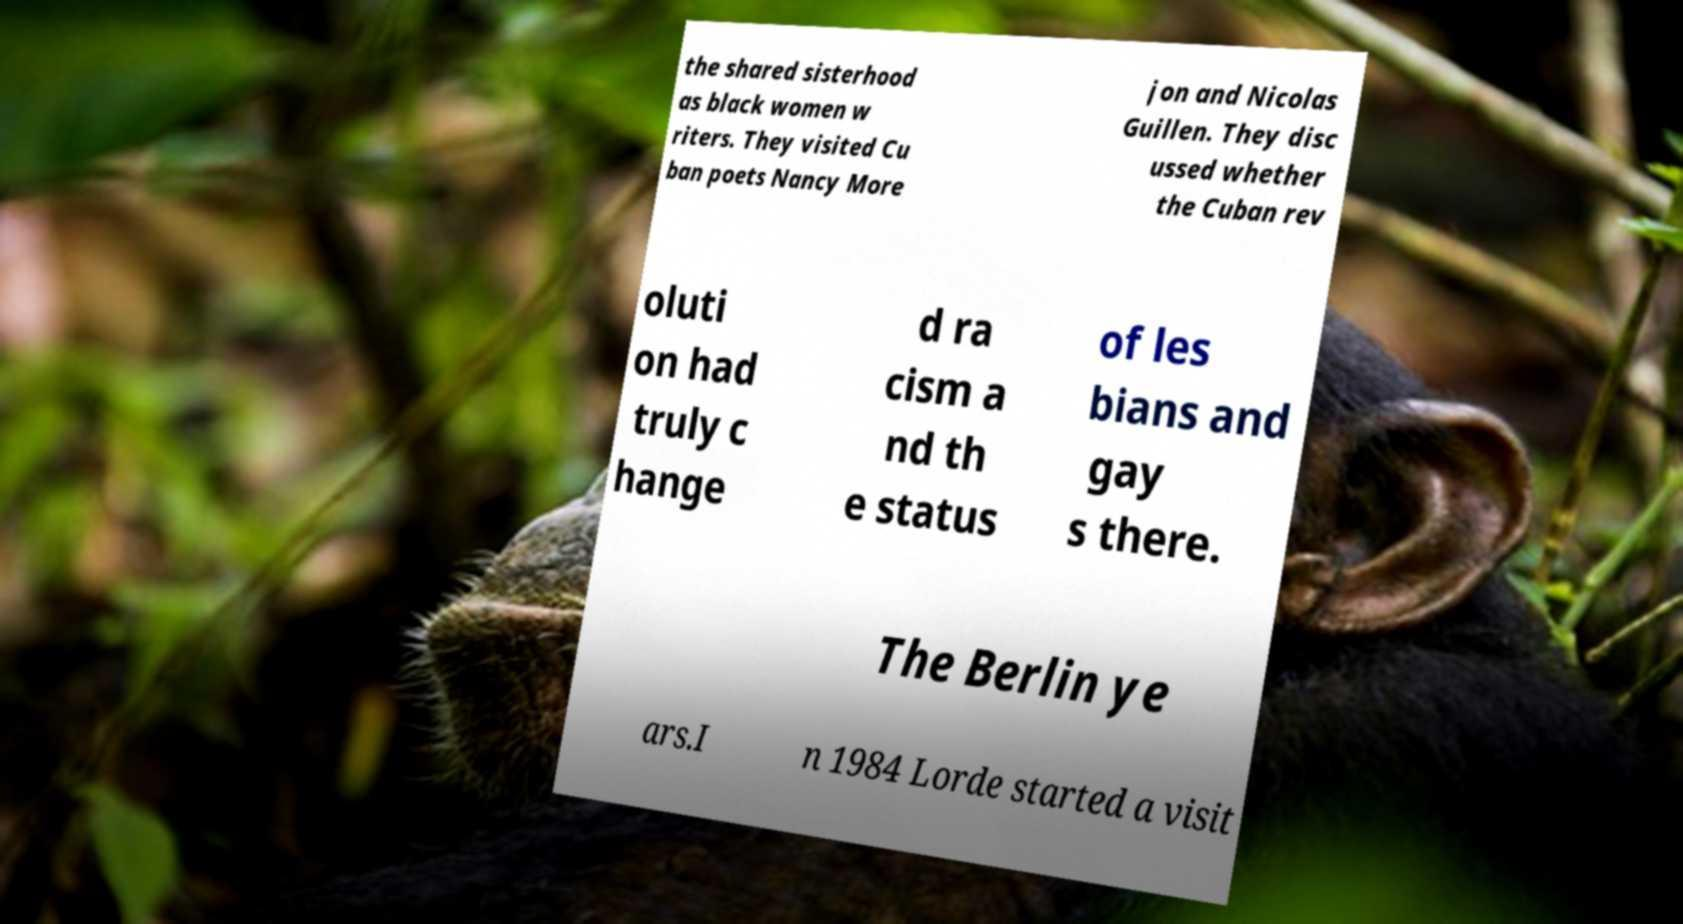Can you accurately transcribe the text from the provided image for me? the shared sisterhood as black women w riters. They visited Cu ban poets Nancy More jon and Nicolas Guillen. They disc ussed whether the Cuban rev oluti on had truly c hange d ra cism a nd th e status of les bians and gay s there. The Berlin ye ars.I n 1984 Lorde started a visit 